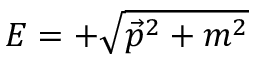<formula> <loc_0><loc_0><loc_500><loc_500>E = + { \sqrt { { \vec { p } } ^ { 2 } + m ^ { 2 } } }</formula> 